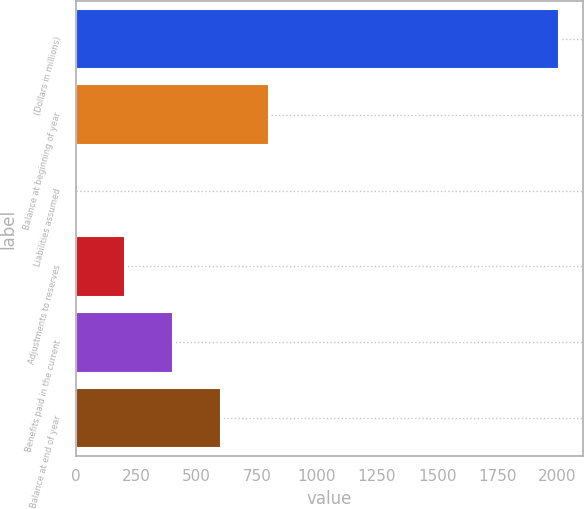Convert chart to OTSL. <chart><loc_0><loc_0><loc_500><loc_500><bar_chart><fcel>(Dollars in millions)<fcel>Balance at beginning of year<fcel>Liabilities assumed<fcel>Adjustments to reserves<fcel>Benefits paid in the current<fcel>Balance at end of year<nl><fcel>2006<fcel>802.58<fcel>0.3<fcel>200.87<fcel>401.44<fcel>602.01<nl></chart> 